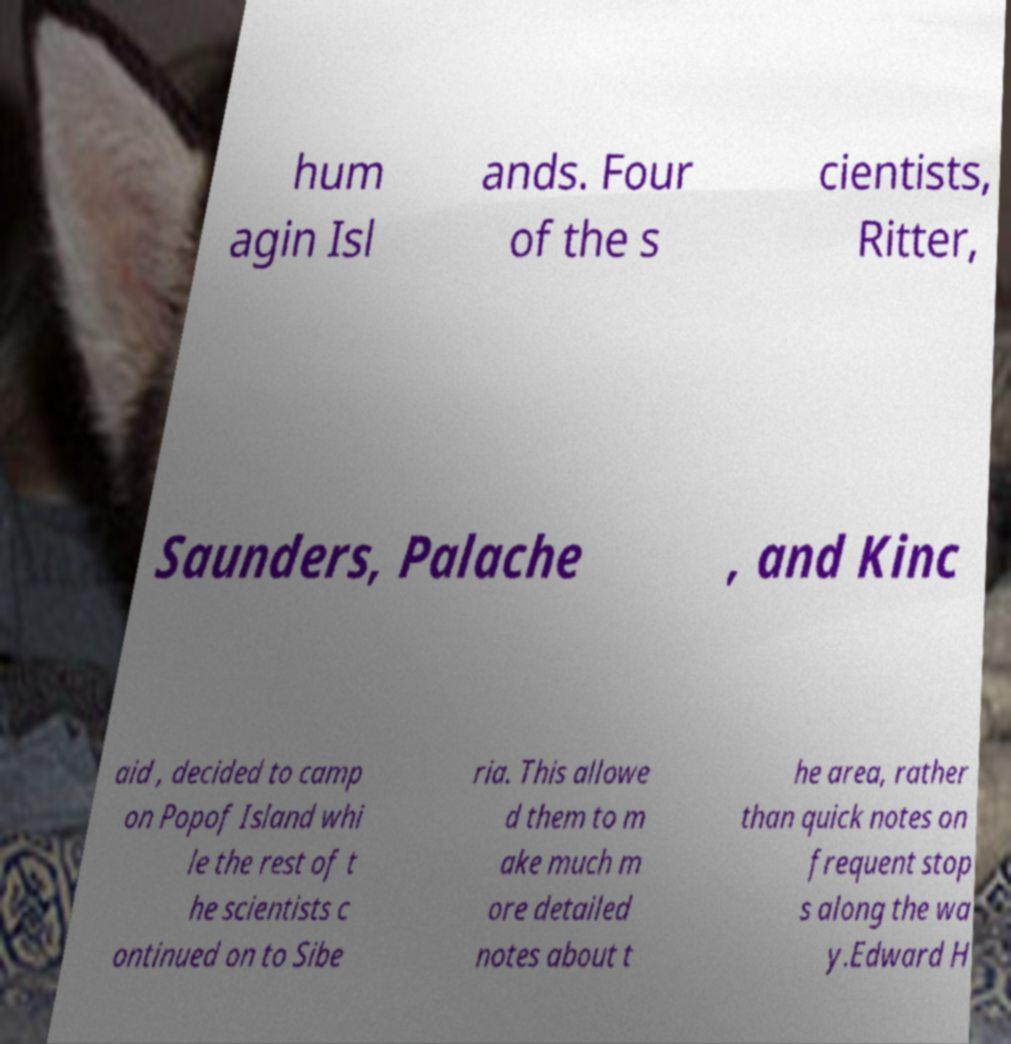Can you accurately transcribe the text from the provided image for me? hum agin Isl ands. Four of the s cientists, Ritter, Saunders, Palache , and Kinc aid , decided to camp on Popof Island whi le the rest of t he scientists c ontinued on to Sibe ria. This allowe d them to m ake much m ore detailed notes about t he area, rather than quick notes on frequent stop s along the wa y.Edward H 